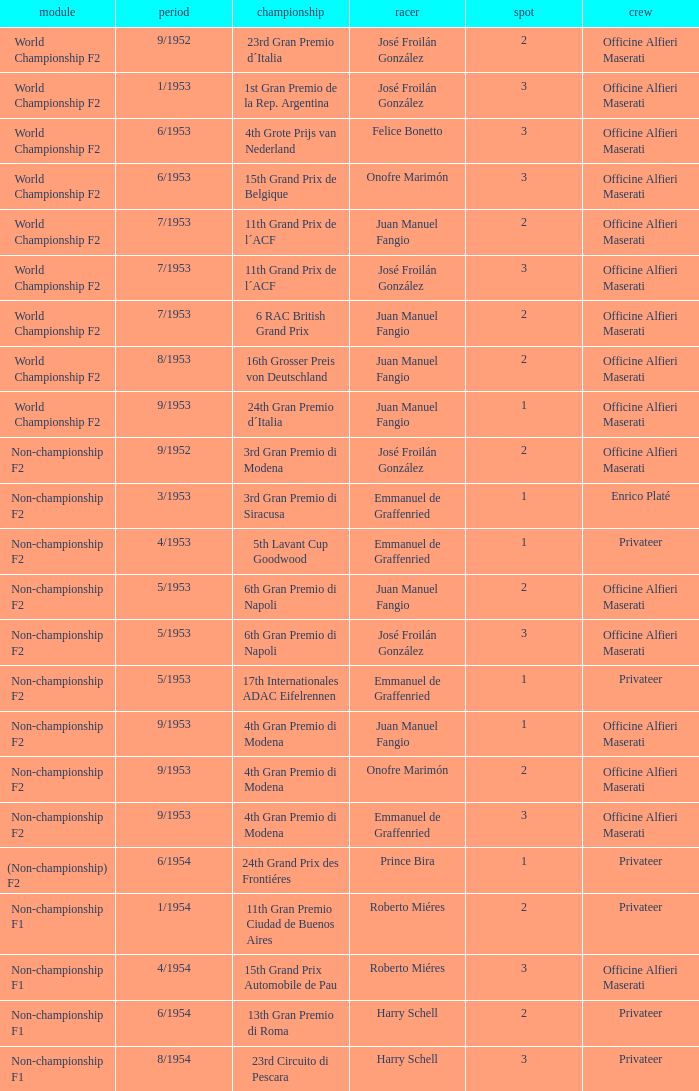Write the full table. {'header': ['module', 'period', 'championship', 'racer', 'spot', 'crew'], 'rows': [['World Championship F2', '9/1952', '23rd Gran Premio d´Italia', 'José Froilán González', '2', 'Officine Alfieri Maserati'], ['World Championship F2', '1/1953', '1st Gran Premio de la Rep. Argentina', 'José Froilán González', '3', 'Officine Alfieri Maserati'], ['World Championship F2', '6/1953', '4th Grote Prijs van Nederland', 'Felice Bonetto', '3', 'Officine Alfieri Maserati'], ['World Championship F2', '6/1953', '15th Grand Prix de Belgique', 'Onofre Marimón', '3', 'Officine Alfieri Maserati'], ['World Championship F2', '7/1953', '11th Grand Prix de l´ACF', 'Juan Manuel Fangio', '2', 'Officine Alfieri Maserati'], ['World Championship F2', '7/1953', '11th Grand Prix de l´ACF', 'José Froilán González', '3', 'Officine Alfieri Maserati'], ['World Championship F2', '7/1953', '6 RAC British Grand Prix', 'Juan Manuel Fangio', '2', 'Officine Alfieri Maserati'], ['World Championship F2', '8/1953', '16th Grosser Preis von Deutschland', 'Juan Manuel Fangio', '2', 'Officine Alfieri Maserati'], ['World Championship F2', '9/1953', '24th Gran Premio d´Italia', 'Juan Manuel Fangio', '1', 'Officine Alfieri Maserati'], ['Non-championship F2', '9/1952', '3rd Gran Premio di Modena', 'José Froilán González', '2', 'Officine Alfieri Maserati'], ['Non-championship F2', '3/1953', '3rd Gran Premio di Siracusa', 'Emmanuel de Graffenried', '1', 'Enrico Platé'], ['Non-championship F2', '4/1953', '5th Lavant Cup Goodwood', 'Emmanuel de Graffenried', '1', 'Privateer'], ['Non-championship F2', '5/1953', '6th Gran Premio di Napoli', 'Juan Manuel Fangio', '2', 'Officine Alfieri Maserati'], ['Non-championship F2', '5/1953', '6th Gran Premio di Napoli', 'José Froilán González', '3', 'Officine Alfieri Maserati'], ['Non-championship F2', '5/1953', '17th Internationales ADAC Eifelrennen', 'Emmanuel de Graffenried', '1', 'Privateer'], ['Non-championship F2', '9/1953', '4th Gran Premio di Modena', 'Juan Manuel Fangio', '1', 'Officine Alfieri Maserati'], ['Non-championship F2', '9/1953', '4th Gran Premio di Modena', 'Onofre Marimón', '2', 'Officine Alfieri Maserati'], ['Non-championship F2', '9/1953', '4th Gran Premio di Modena', 'Emmanuel de Graffenried', '3', 'Officine Alfieri Maserati'], ['(Non-championship) F2', '6/1954', '24th Grand Prix des Frontiéres', 'Prince Bira', '1', 'Privateer'], ['Non-championship F1', '1/1954', '11th Gran Premio Ciudad de Buenos Aires', 'Roberto Miéres', '2', 'Privateer'], ['Non-championship F1', '4/1954', '15th Grand Prix Automobile de Pau', 'Roberto Miéres', '3', 'Officine Alfieri Maserati'], ['Non-championship F1', '6/1954', '13th Gran Premio di Roma', 'Harry Schell', '2', 'Privateer'], ['Non-championship F1', '8/1954', '23rd Circuito di Pescara', 'Harry Schell', '3', 'Privateer']]} What date has the class of non-championship f2 as well as a driver name josé froilán gonzález that has a position larger than 2? 5/1953. 